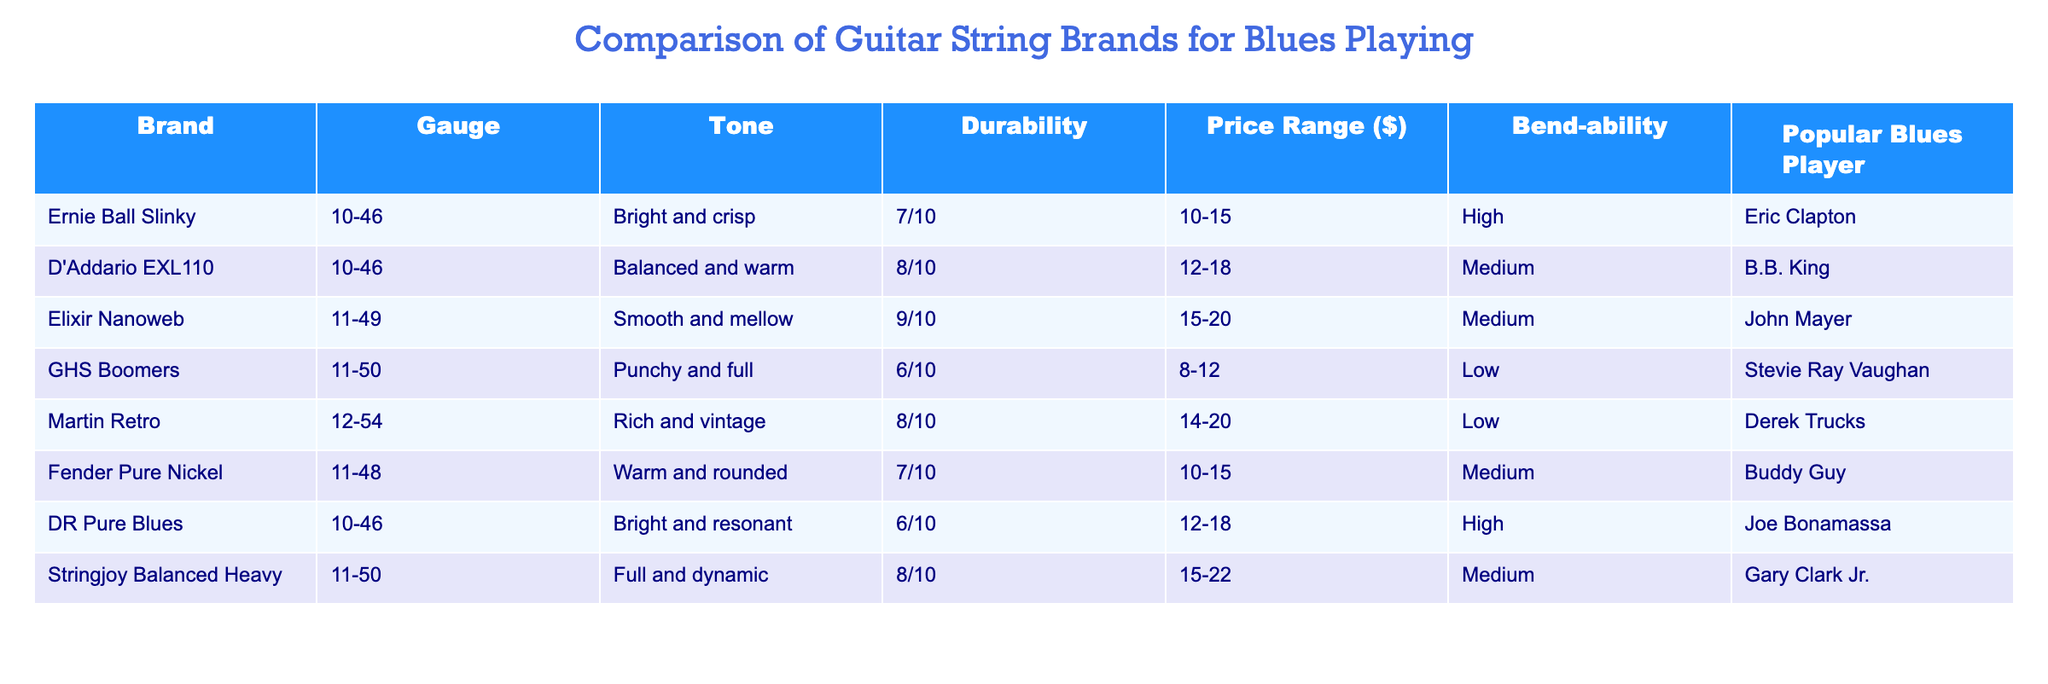What is the gauge range of the D'Addario EXL110 strings? The D'Addario EXL110 strings are listed in the table with a gauge of 10-46. The gauge column identifies the measurement of the strings' thickness, and there is no other gauge provided for this brand in the table.
Answer: 10-46 Which string brand has the highest durability rating? Looking at the durability ratings in the table, the Elixir Nanoweb has a rating of 9/10, which is the highest among the listed brands. I compared the durability ratings from each row to find the maximum value.
Answer: Elixir Nanoweb What is the price range difference between GHS Boomers and Stringjoy Balanced Heavy? The price range for GHS Boomers is 8-12 dollars and for Stringjoy Balanced Heavy, it is 15-22 dollars. The difference in price range can be calculated by subtracting the lower end of GHS Boomers (8) from the higher end of Stringjoy (22) to get 22 - 8 = 14 dollars.
Answer: 14 Do any guitar string brands listed have a medium bend-ability rating? By reviewing the bend-ability ratings in the table, I look for brands that specifically list 'Medium'. The brands that have this rating are D'Addario EXL110, Fender Pure Nickel, and Stringjoy Balanced Heavy. Therefore, it is true that multiple brands have a medium rating.
Answer: Yes Which brand is associated with the blues player Eric Clapton, and what is its tone? Eric Clapton is associated with the Ernie Ball Slinky brand according to the Popular Blues Player column. Referring to the tone column, the tone for Ernie Ball Slinky strings is described as 'Bright and crisp'. Both pieces of information can be found in the corresponding row for Ernie Ball Slinky.
Answer: Ernie Ball Slinky, Bright and crisp If a player prefers a warm tone, which brands would be suitable? From the table, I identify brands that have a tone description related to 'warm'. The D'Addario EXL110 and Fender Pure Nickel offer 'Balanced and warm' and 'Warm and rounded' tones, respectively. Therefore, a player could choose either of these brands based on their warmth preference.
Answer: D'Addario EXL110, Fender Pure Nickel What is the average durability rating of the brands associated with popular blues players? To calculate the average durability, I first identify the durability ratings: 7, 8, 9, 6, 8, 7, 6, 8. I sum these values: 7 + 8 + 9 + 6 + 8 + 7 + 6 + 8 = 59. With 8 data points, I divide the total by 8: 59 / 8 = 7.375. So, the average durability rating is approximately 7.38.
Answer: 7.375 